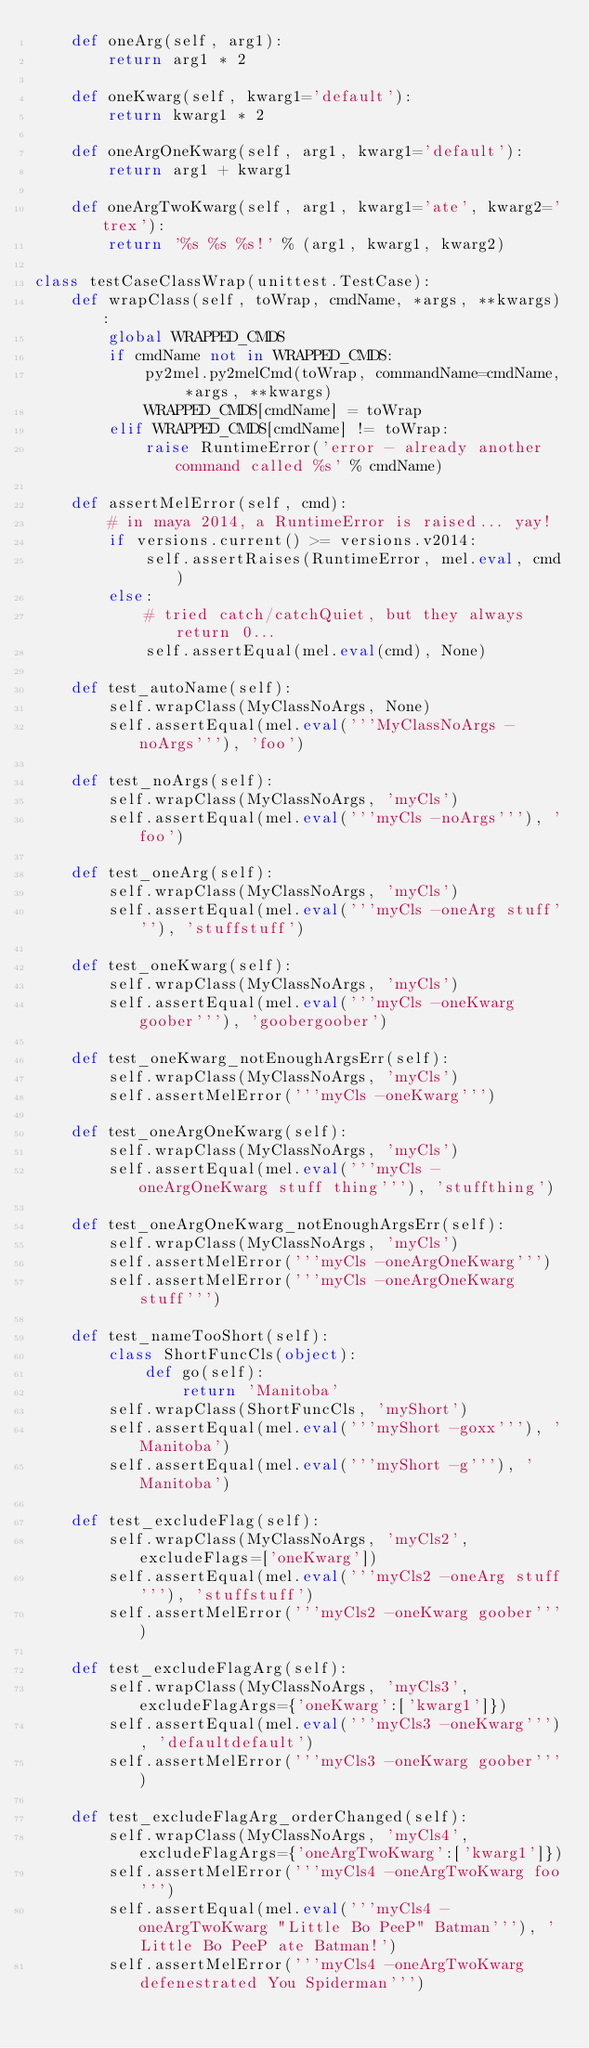Convert code to text. <code><loc_0><loc_0><loc_500><loc_500><_Python_>    def oneArg(self, arg1):
        return arg1 * 2

    def oneKwarg(self, kwarg1='default'):
        return kwarg1 * 2

    def oneArgOneKwarg(self, arg1, kwarg1='default'):
        return arg1 + kwarg1

    def oneArgTwoKwarg(self, arg1, kwarg1='ate', kwarg2='trex'):
        return '%s %s %s!' % (arg1, kwarg1, kwarg2)

class testCaseClassWrap(unittest.TestCase):
    def wrapClass(self, toWrap, cmdName, *args, **kwargs):
        global WRAPPED_CMDS
        if cmdName not in WRAPPED_CMDS:
            py2mel.py2melCmd(toWrap, commandName=cmdName, *args, **kwargs)
            WRAPPED_CMDS[cmdName] = toWrap
        elif WRAPPED_CMDS[cmdName] != toWrap:
            raise RuntimeError('error - already another command called %s' % cmdName)

    def assertMelError(self, cmd):
        # in maya 2014, a RuntimeError is raised... yay!
        if versions.current() >= versions.v2014:
            self.assertRaises(RuntimeError, mel.eval, cmd)
        else:
            # tried catch/catchQuiet, but they always return 0...
            self.assertEqual(mel.eval(cmd), None)

    def test_autoName(self):
        self.wrapClass(MyClassNoArgs, None)
        self.assertEqual(mel.eval('''MyClassNoArgs -noArgs'''), 'foo')

    def test_noArgs(self):
        self.wrapClass(MyClassNoArgs, 'myCls')
        self.assertEqual(mel.eval('''myCls -noArgs'''), 'foo')

    def test_oneArg(self):
        self.wrapClass(MyClassNoArgs, 'myCls')
        self.assertEqual(mel.eval('''myCls -oneArg stuff'''), 'stuffstuff')

    def test_oneKwarg(self):
        self.wrapClass(MyClassNoArgs, 'myCls')
        self.assertEqual(mel.eval('''myCls -oneKwarg goober'''), 'goobergoober')

    def test_oneKwarg_notEnoughArgsErr(self):
        self.wrapClass(MyClassNoArgs, 'myCls')
        self.assertMelError('''myCls -oneKwarg''')

    def test_oneArgOneKwarg(self):
        self.wrapClass(MyClassNoArgs, 'myCls')
        self.assertEqual(mel.eval('''myCls -oneArgOneKwarg stuff thing'''), 'stuffthing')

    def test_oneArgOneKwarg_notEnoughArgsErr(self):
        self.wrapClass(MyClassNoArgs, 'myCls')
        self.assertMelError('''myCls -oneArgOneKwarg''')
        self.assertMelError('''myCls -oneArgOneKwarg stuff''')

    def test_nameTooShort(self):
        class ShortFuncCls(object):
            def go(self):
                return 'Manitoba'
        self.wrapClass(ShortFuncCls, 'myShort')
        self.assertEqual(mel.eval('''myShort -goxx'''), 'Manitoba')
        self.assertEqual(mel.eval('''myShort -g'''), 'Manitoba')

    def test_excludeFlag(self):
        self.wrapClass(MyClassNoArgs, 'myCls2', excludeFlags=['oneKwarg'])
        self.assertEqual(mel.eval('''myCls2 -oneArg stuff'''), 'stuffstuff')
        self.assertMelError('''myCls2 -oneKwarg goober''')

    def test_excludeFlagArg(self):
        self.wrapClass(MyClassNoArgs, 'myCls3', excludeFlagArgs={'oneKwarg':['kwarg1']})
        self.assertEqual(mel.eval('''myCls3 -oneKwarg'''), 'defaultdefault')
        self.assertMelError('''myCls3 -oneKwarg goober''')

    def test_excludeFlagArg_orderChanged(self):
        self.wrapClass(MyClassNoArgs, 'myCls4', excludeFlagArgs={'oneArgTwoKwarg':['kwarg1']})
        self.assertMelError('''myCls4 -oneArgTwoKwarg foo''')
        self.assertEqual(mel.eval('''myCls4 -oneArgTwoKwarg "Little Bo PeeP" Batman'''), 'Little Bo PeeP ate Batman!')
        self.assertMelError('''myCls4 -oneArgTwoKwarg defenestrated You Spiderman''')
</code> 